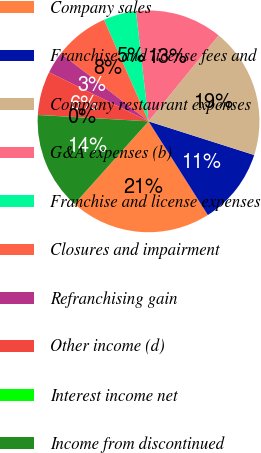Convert chart. <chart><loc_0><loc_0><loc_500><loc_500><pie_chart><fcel>Company sales<fcel>Franchise and license fees and<fcel>Company restaurant expenses<fcel>G&A expenses (b)<fcel>Franchise and license expenses<fcel>Closures and impairment<fcel>Refranchising gain<fcel>Other income (d)<fcel>Interest income net<fcel>Income from discontinued<nl><fcel>20.61%<fcel>11.11%<fcel>19.03%<fcel>12.69%<fcel>4.77%<fcel>7.94%<fcel>3.19%<fcel>6.36%<fcel>0.02%<fcel>14.28%<nl></chart> 